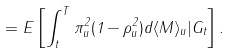Convert formula to latex. <formula><loc_0><loc_0><loc_500><loc_500>= E \left [ \int _ { t } ^ { T } \pi _ { u } ^ { 2 } ( 1 - \rho ^ { 2 } _ { u } ) d \langle M \rangle _ { u } | G _ { t } \right ] .</formula> 